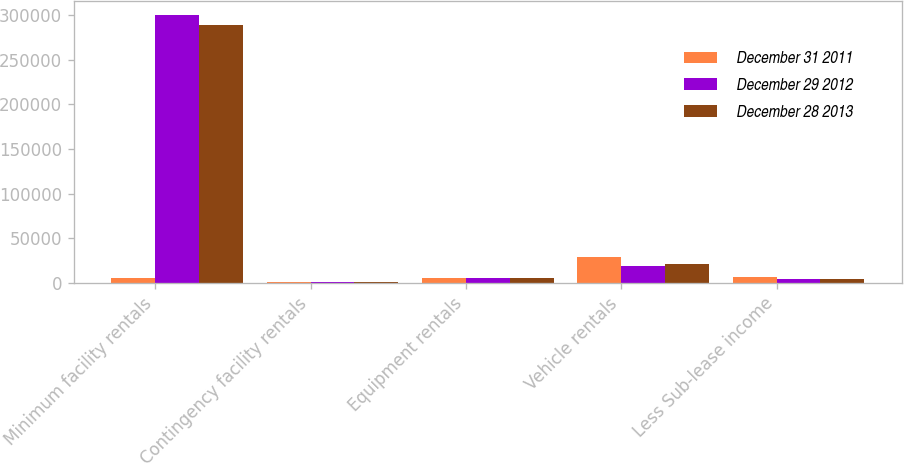Convert chart to OTSL. <chart><loc_0><loc_0><loc_500><loc_500><stacked_bar_chart><ecel><fcel>Minimum facility rentals<fcel>Contingency facility rentals<fcel>Equipment rentals<fcel>Vehicle rentals<fcel>Less Sub-lease income<nl><fcel>December 31 2011<fcel>5368<fcel>578<fcel>5333<fcel>29100<fcel>5983<nl><fcel>December 29 2012<fcel>300552<fcel>907<fcel>5027<fcel>18401<fcel>4600<nl><fcel>December 28 2013<fcel>289306<fcel>1162<fcel>5403<fcel>20565<fcel>3967<nl></chart> 